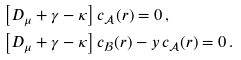Convert formula to latex. <formula><loc_0><loc_0><loc_500><loc_500>& \left [ D _ { \mu } + \gamma - \kappa \right ] c _ { \mathcal { A } } ( r ) = 0 \, , \\ & \left [ D _ { \mu } + \gamma - \kappa \right ] c _ { \mathcal { B } } ( r ) - y \, c _ { \mathcal { A } } ( r ) = 0 \, .</formula> 